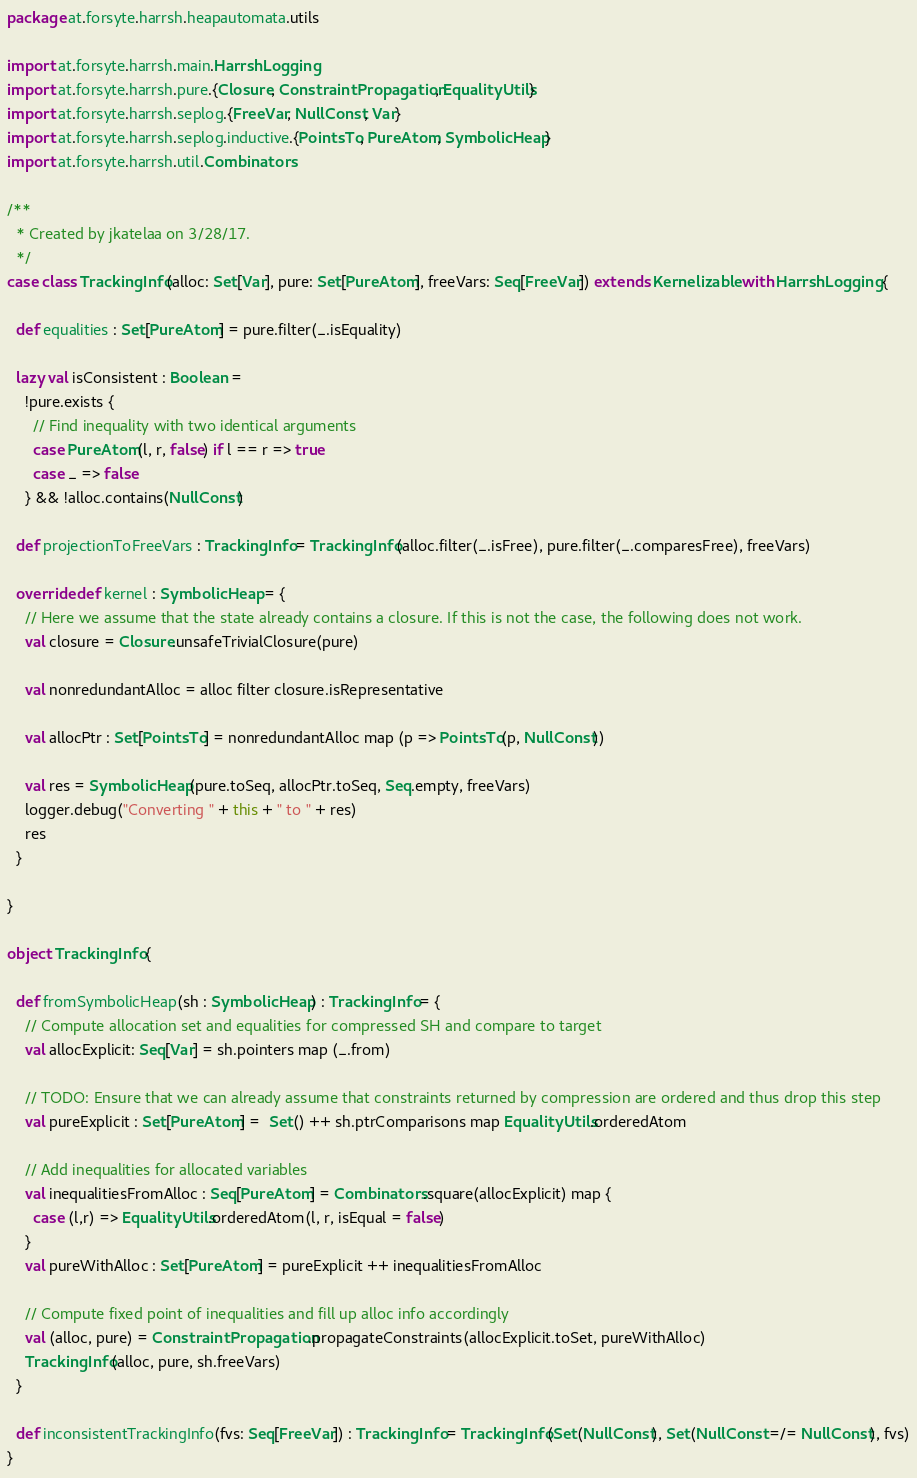<code> <loc_0><loc_0><loc_500><loc_500><_Scala_>package at.forsyte.harrsh.heapautomata.utils

import at.forsyte.harrsh.main.HarrshLogging
import at.forsyte.harrsh.pure.{Closure, ConstraintPropagation, EqualityUtils}
import at.forsyte.harrsh.seplog.{FreeVar, NullConst, Var}
import at.forsyte.harrsh.seplog.inductive.{PointsTo, PureAtom, SymbolicHeap}
import at.forsyte.harrsh.util.Combinators

/**
  * Created by jkatelaa on 3/28/17.
  */
case class TrackingInfo(alloc: Set[Var], pure: Set[PureAtom], freeVars: Seq[FreeVar]) extends Kernelizable with HarrshLogging {

  def equalities : Set[PureAtom] = pure.filter(_.isEquality)

  lazy val isConsistent : Boolean =
    !pure.exists {
      // Find inequality with two identical arguments
      case PureAtom(l, r, false) if l == r => true
      case _ => false
    } && !alloc.contains(NullConst)

  def projectionToFreeVars : TrackingInfo = TrackingInfo(alloc.filter(_.isFree), pure.filter(_.comparesFree), freeVars)

  override def kernel : SymbolicHeap = {
    // Here we assume that the state already contains a closure. If this is not the case, the following does not work.
    val closure = Closure.unsafeTrivialClosure(pure)

    val nonredundantAlloc = alloc filter closure.isRepresentative

    val allocPtr : Set[PointsTo] = nonredundantAlloc map (p => PointsTo(p, NullConst))

    val res = SymbolicHeap(pure.toSeq, allocPtr.toSeq, Seq.empty, freeVars)
    logger.debug("Converting " + this + " to " + res)
    res
  }

}

object TrackingInfo {

  def fromSymbolicHeap(sh : SymbolicHeap) : TrackingInfo = {
    // Compute allocation set and equalities for compressed SH and compare to target
    val allocExplicit: Seq[Var] = sh.pointers map (_.from)

    // TODO: Ensure that we can already assume that constraints returned by compression are ordered and thus drop this step
    val pureExplicit : Set[PureAtom] =  Set() ++ sh.ptrComparisons map EqualityUtils.orderedAtom

    // Add inequalities for allocated variables
    val inequalitiesFromAlloc : Seq[PureAtom] = Combinators.square(allocExplicit) map {
      case (l,r) => EqualityUtils.orderedAtom(l, r, isEqual = false)
    }
    val pureWithAlloc : Set[PureAtom] = pureExplicit ++ inequalitiesFromAlloc

    // Compute fixed point of inequalities and fill up alloc info accordingly
    val (alloc, pure) = ConstraintPropagation.propagateConstraints(allocExplicit.toSet, pureWithAlloc)
    TrackingInfo(alloc, pure, sh.freeVars)
  }

  def inconsistentTrackingInfo(fvs: Seq[FreeVar]) : TrackingInfo = TrackingInfo(Set(NullConst), Set(NullConst =/= NullConst), fvs)
}</code> 